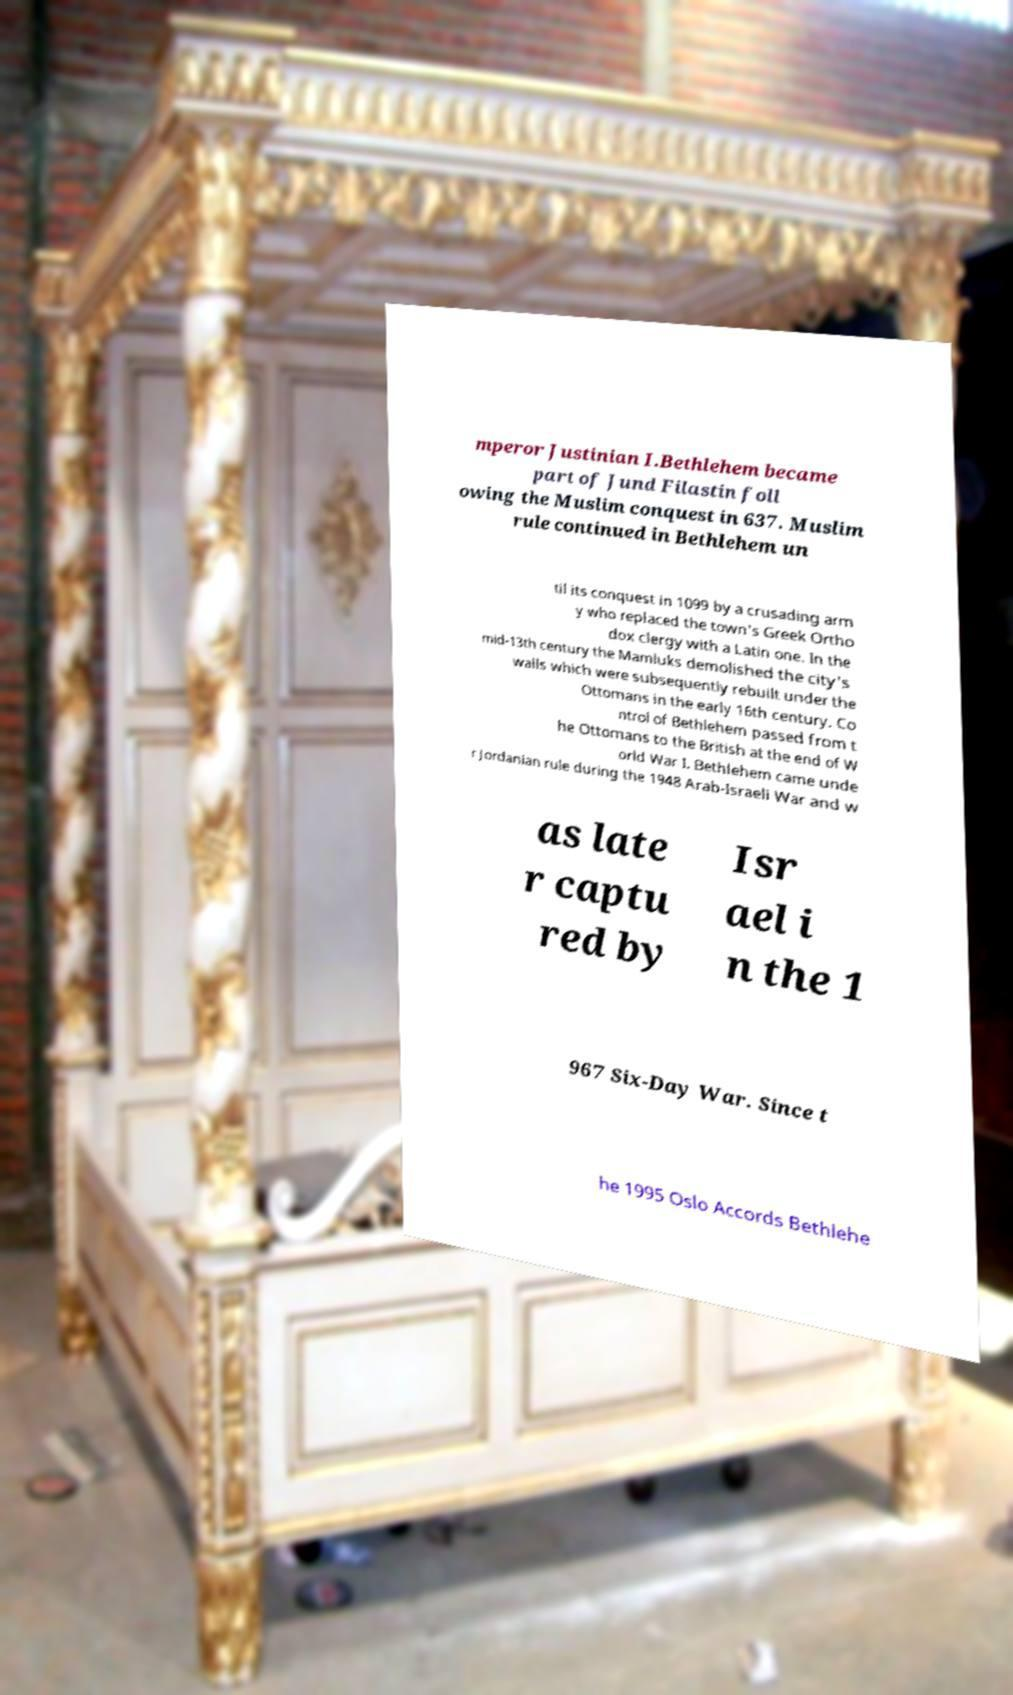Could you extract and type out the text from this image? mperor Justinian I.Bethlehem became part of Jund Filastin foll owing the Muslim conquest in 637. Muslim rule continued in Bethlehem un til its conquest in 1099 by a crusading arm y who replaced the town's Greek Ortho dox clergy with a Latin one. In the mid-13th century the Mamluks demolished the city's walls which were subsequently rebuilt under the Ottomans in the early 16th century. Co ntrol of Bethlehem passed from t he Ottomans to the British at the end of W orld War I. Bethlehem came unde r Jordanian rule during the 1948 Arab-Israeli War and w as late r captu red by Isr ael i n the 1 967 Six-Day War. Since t he 1995 Oslo Accords Bethlehe 